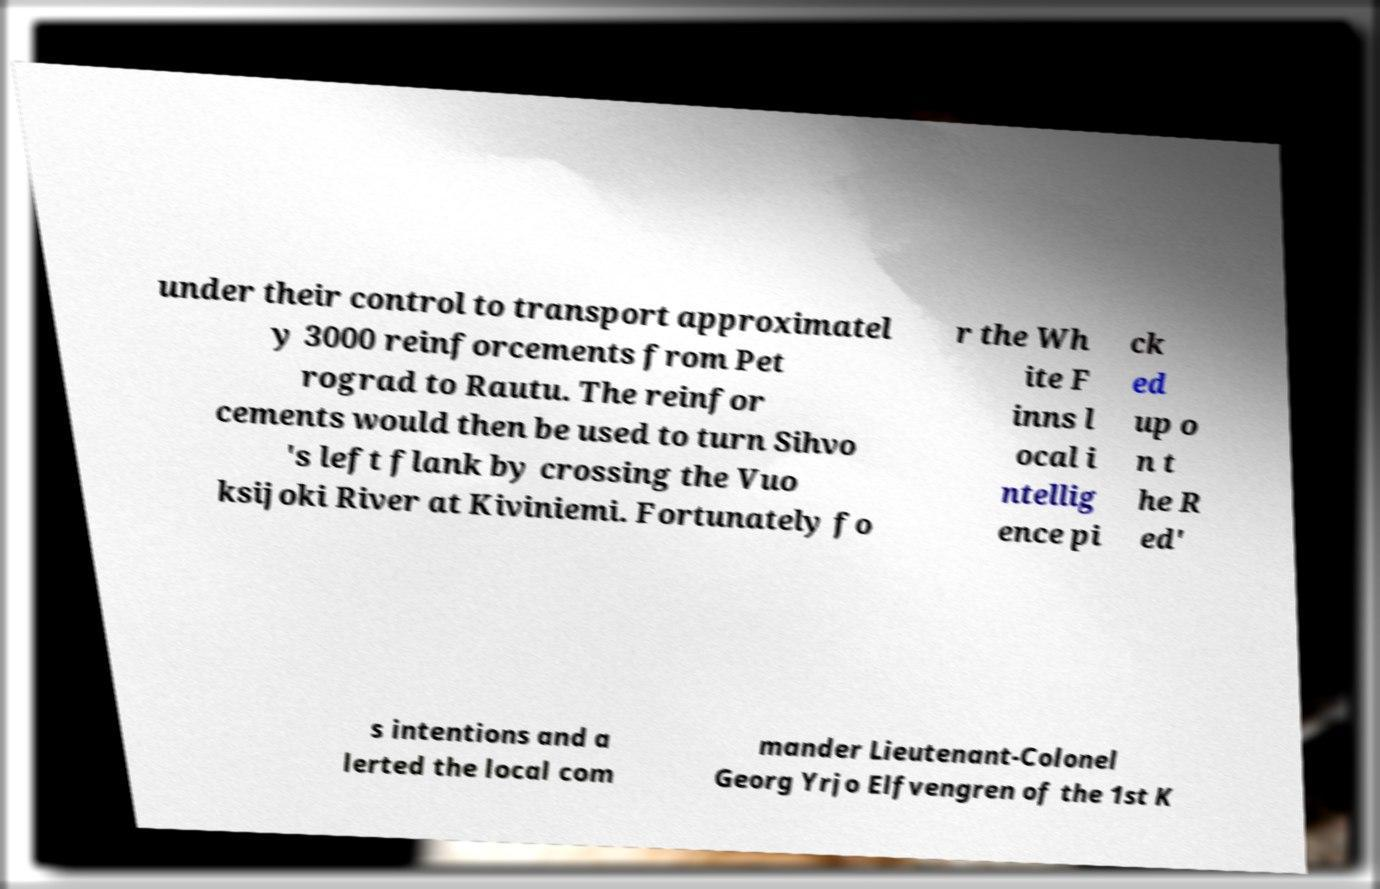What messages or text are displayed in this image? I need them in a readable, typed format. under their control to transport approximatel y 3000 reinforcements from Pet rograd to Rautu. The reinfor cements would then be used to turn Sihvo 's left flank by crossing the Vuo ksijoki River at Kiviniemi. Fortunately fo r the Wh ite F inns l ocal i ntellig ence pi ck ed up o n t he R ed' s intentions and a lerted the local com mander Lieutenant-Colonel Georg Yrjo Elfvengren of the 1st K 